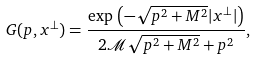Convert formula to latex. <formula><loc_0><loc_0><loc_500><loc_500>G ( p , x ^ { \perp } ) = \frac { \exp \, \left ( - \sqrt { p ^ { 2 } + M ^ { 2 } } | x ^ { \perp } | \right ) } { 2 \mathcal { M } \sqrt { p ^ { 2 } + M ^ { 2 } } + p ^ { 2 } } ,</formula> 